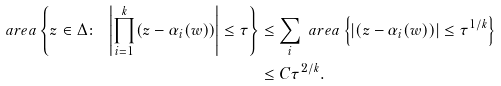<formula> <loc_0><loc_0><loc_500><loc_500>\ a r e a \left \{ z \in \Delta \colon \ \left | \prod _ { i = 1 } ^ { k } ( z - \alpha _ { i } ( w ) ) \right | \leq \tau \right \} & \leq \sum _ { i } \ a r e a \left \{ \left | ( z - \alpha _ { i } ( w ) ) \right | \leq \tau ^ { 1 / k } \right \} \\ & \leq C \tau ^ { 2 / k } .</formula> 